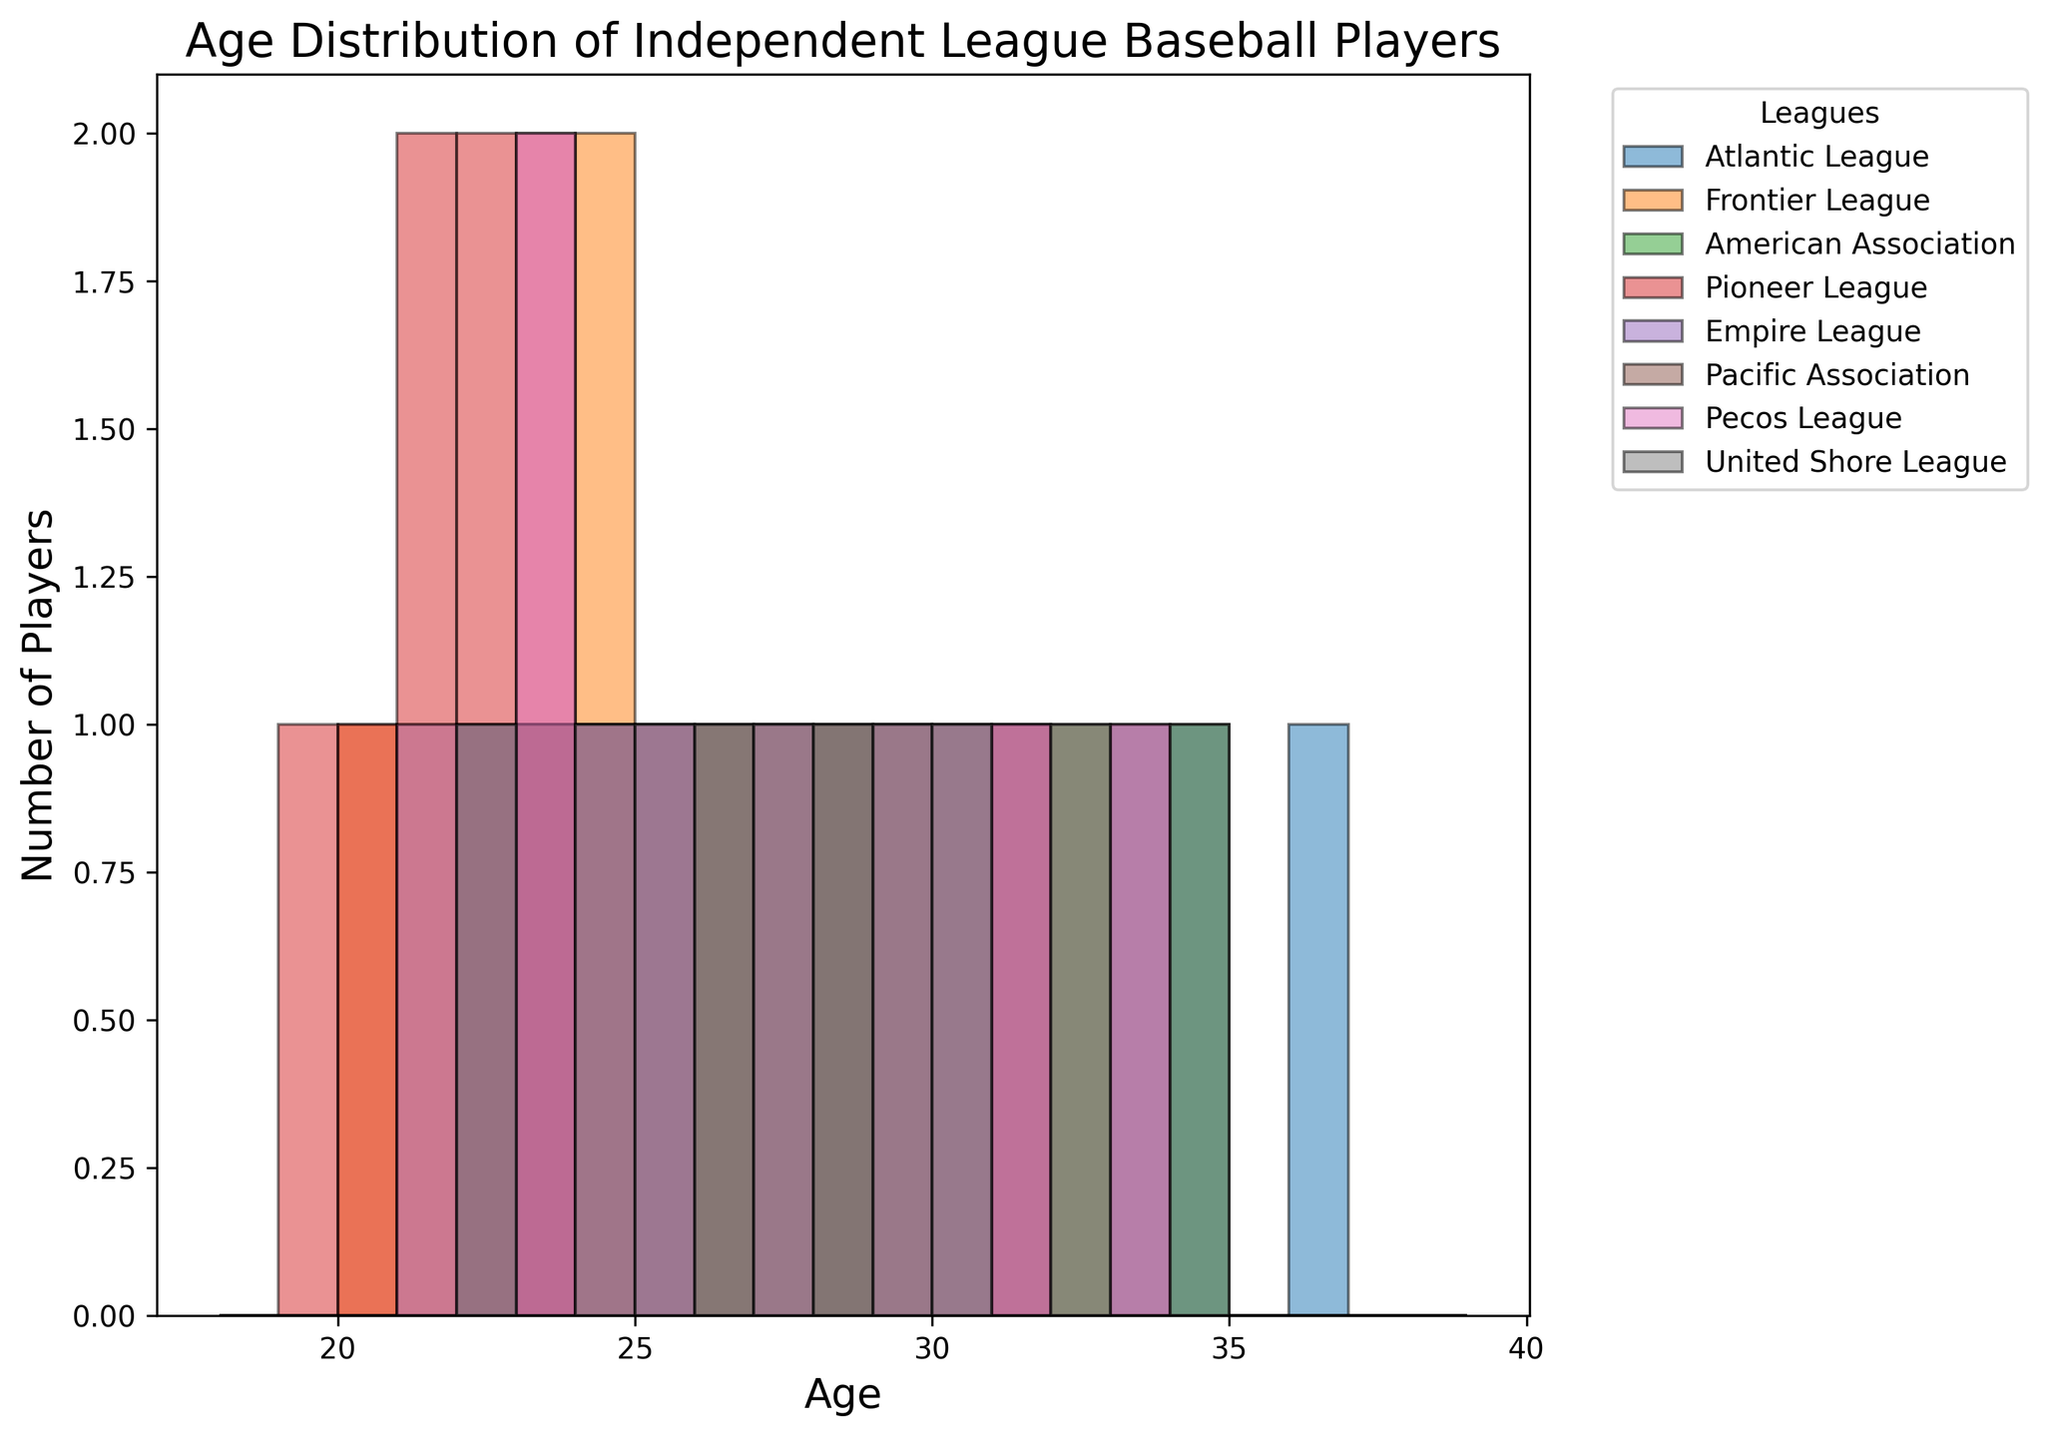What’s the league with the highest number of players aged 27? From the figure, identify the bar corresponding to age 27 for each league. The tallest bar would indicate the league with the highest number of players at that age.
Answer: Atlantic League Which league has the widest range of player ages? Look for the league with the widest span between the lowest and highest age values. Identify the age spans for each league visually.
Answer: Pioneer League Between the American Association and the Frontier League, which has more players aged 29? Compare the height of the bars corresponding to age 29 for both the American Association and the Frontier League. The taller bar indicates more players.
Answer: American Association What’s the average age of players in the Atlantic League? Sum the ages of players in the Atlantic League and divide by the number of players (22 + 25 + 27 + 30 + 28 + 34 + 29 + 36 + 31 + 33)/10.
Answer: 29.5 How many players are there between ages 21 and 25 in the Pioneer League? Identify and sum the heights of bars from ages 21 to 25 for the Pioneer League. Ages: 21 (2), 22 (2), 23 (2), 24 (1), 25 (1). Total = 2 + 2 + 2 + 1 + 1 = 8.
Answer: 8 Which age has the highest number of players across all leagues combined? Identify the tallest bar across all ages in the histogram.
Answer: 23 In the Frontier League, which two ages have the closest number of players? Compare the heights of the bars within the Frontier League's age range and identify the two with the smallest difference.
Answer: 24 and 28 What’s the most frequent age of players in the United Shore League? Look for the tallest bar in the United Shore League category.
Answer: 34 